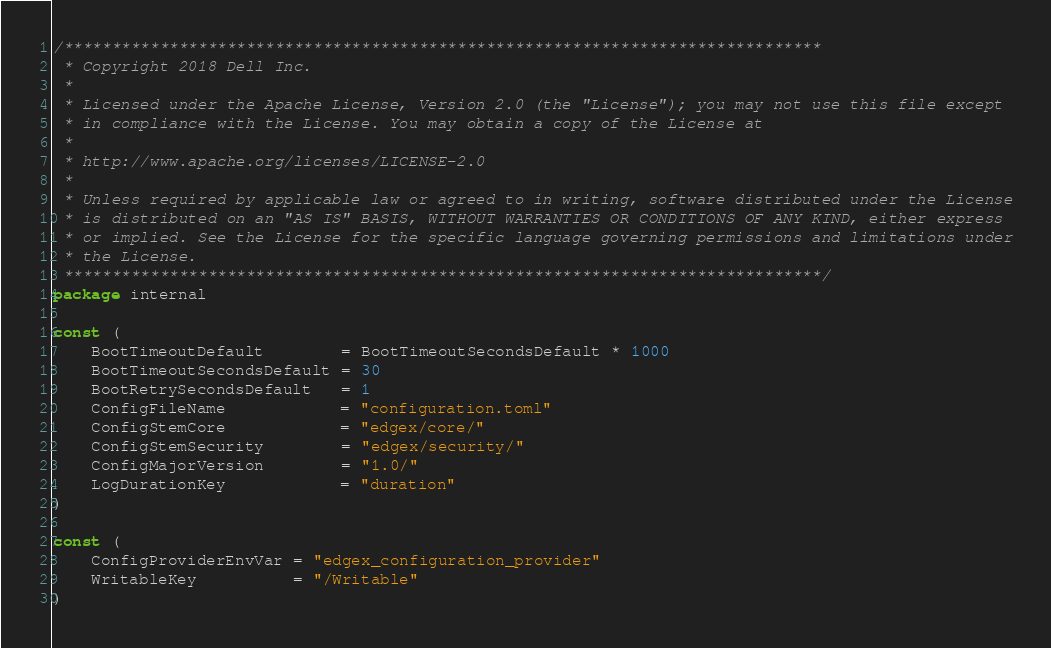Convert code to text. <code><loc_0><loc_0><loc_500><loc_500><_Go_>/*******************************************************************************
 * Copyright 2018 Dell Inc.
 *
 * Licensed under the Apache License, Version 2.0 (the "License"); you may not use this file except
 * in compliance with the License. You may obtain a copy of the License at
 *
 * http://www.apache.org/licenses/LICENSE-2.0
 *
 * Unless required by applicable law or agreed to in writing, software distributed under the License
 * is distributed on an "AS IS" BASIS, WITHOUT WARRANTIES OR CONDITIONS OF ANY KIND, either express
 * or implied. See the License for the specific language governing permissions and limitations under
 * the License.
 *******************************************************************************/
package internal

const (
	BootTimeoutDefault        = BootTimeoutSecondsDefault * 1000
	BootTimeoutSecondsDefault = 30
	BootRetrySecondsDefault   = 1
	ConfigFileName            = "configuration.toml"
	ConfigStemCore            = "edgex/core/"
	ConfigStemSecurity        = "edgex/security/"
	ConfigMajorVersion        = "1.0/"
	LogDurationKey            = "duration"
)

const (
	ConfigProviderEnvVar = "edgex_configuration_provider"
	WritableKey          = "/Writable"
)
</code> 